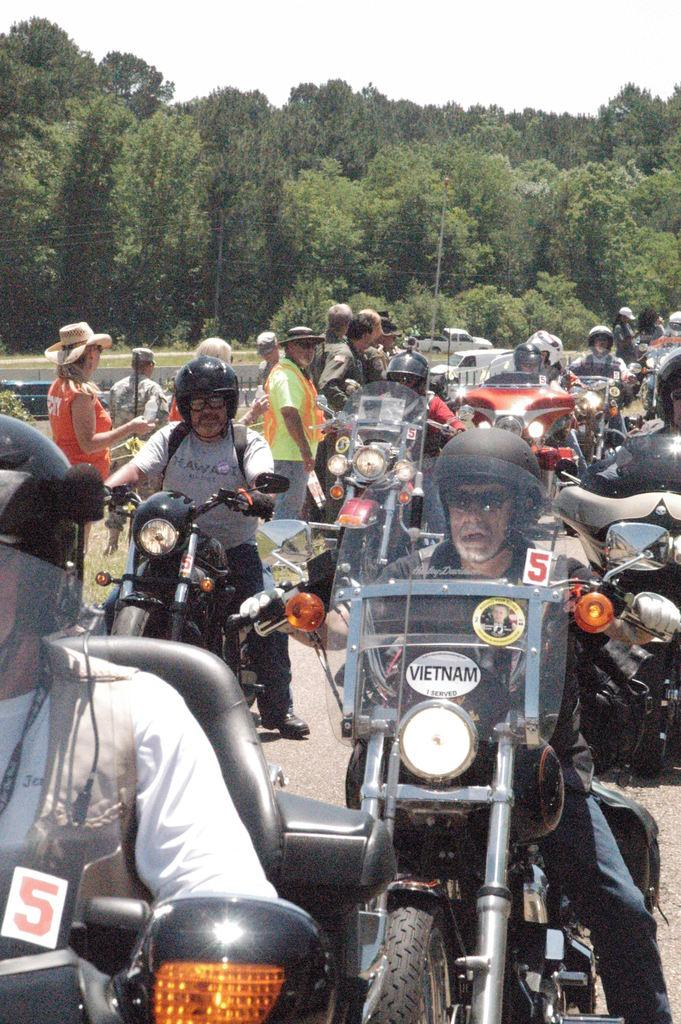What are the people in the image doing? There are people on bikes and people standing in the image. Can you describe the background of the image? There are trees in the background of the image. What type of protest is happening in the image? There is no protest present in the image; it features people on bikes and standing with trees in the background. What is the zephyr's role in the image? There is no zephyr present in the image; it is a term used to describe a gentle breeze, which is not depicted in the image. 